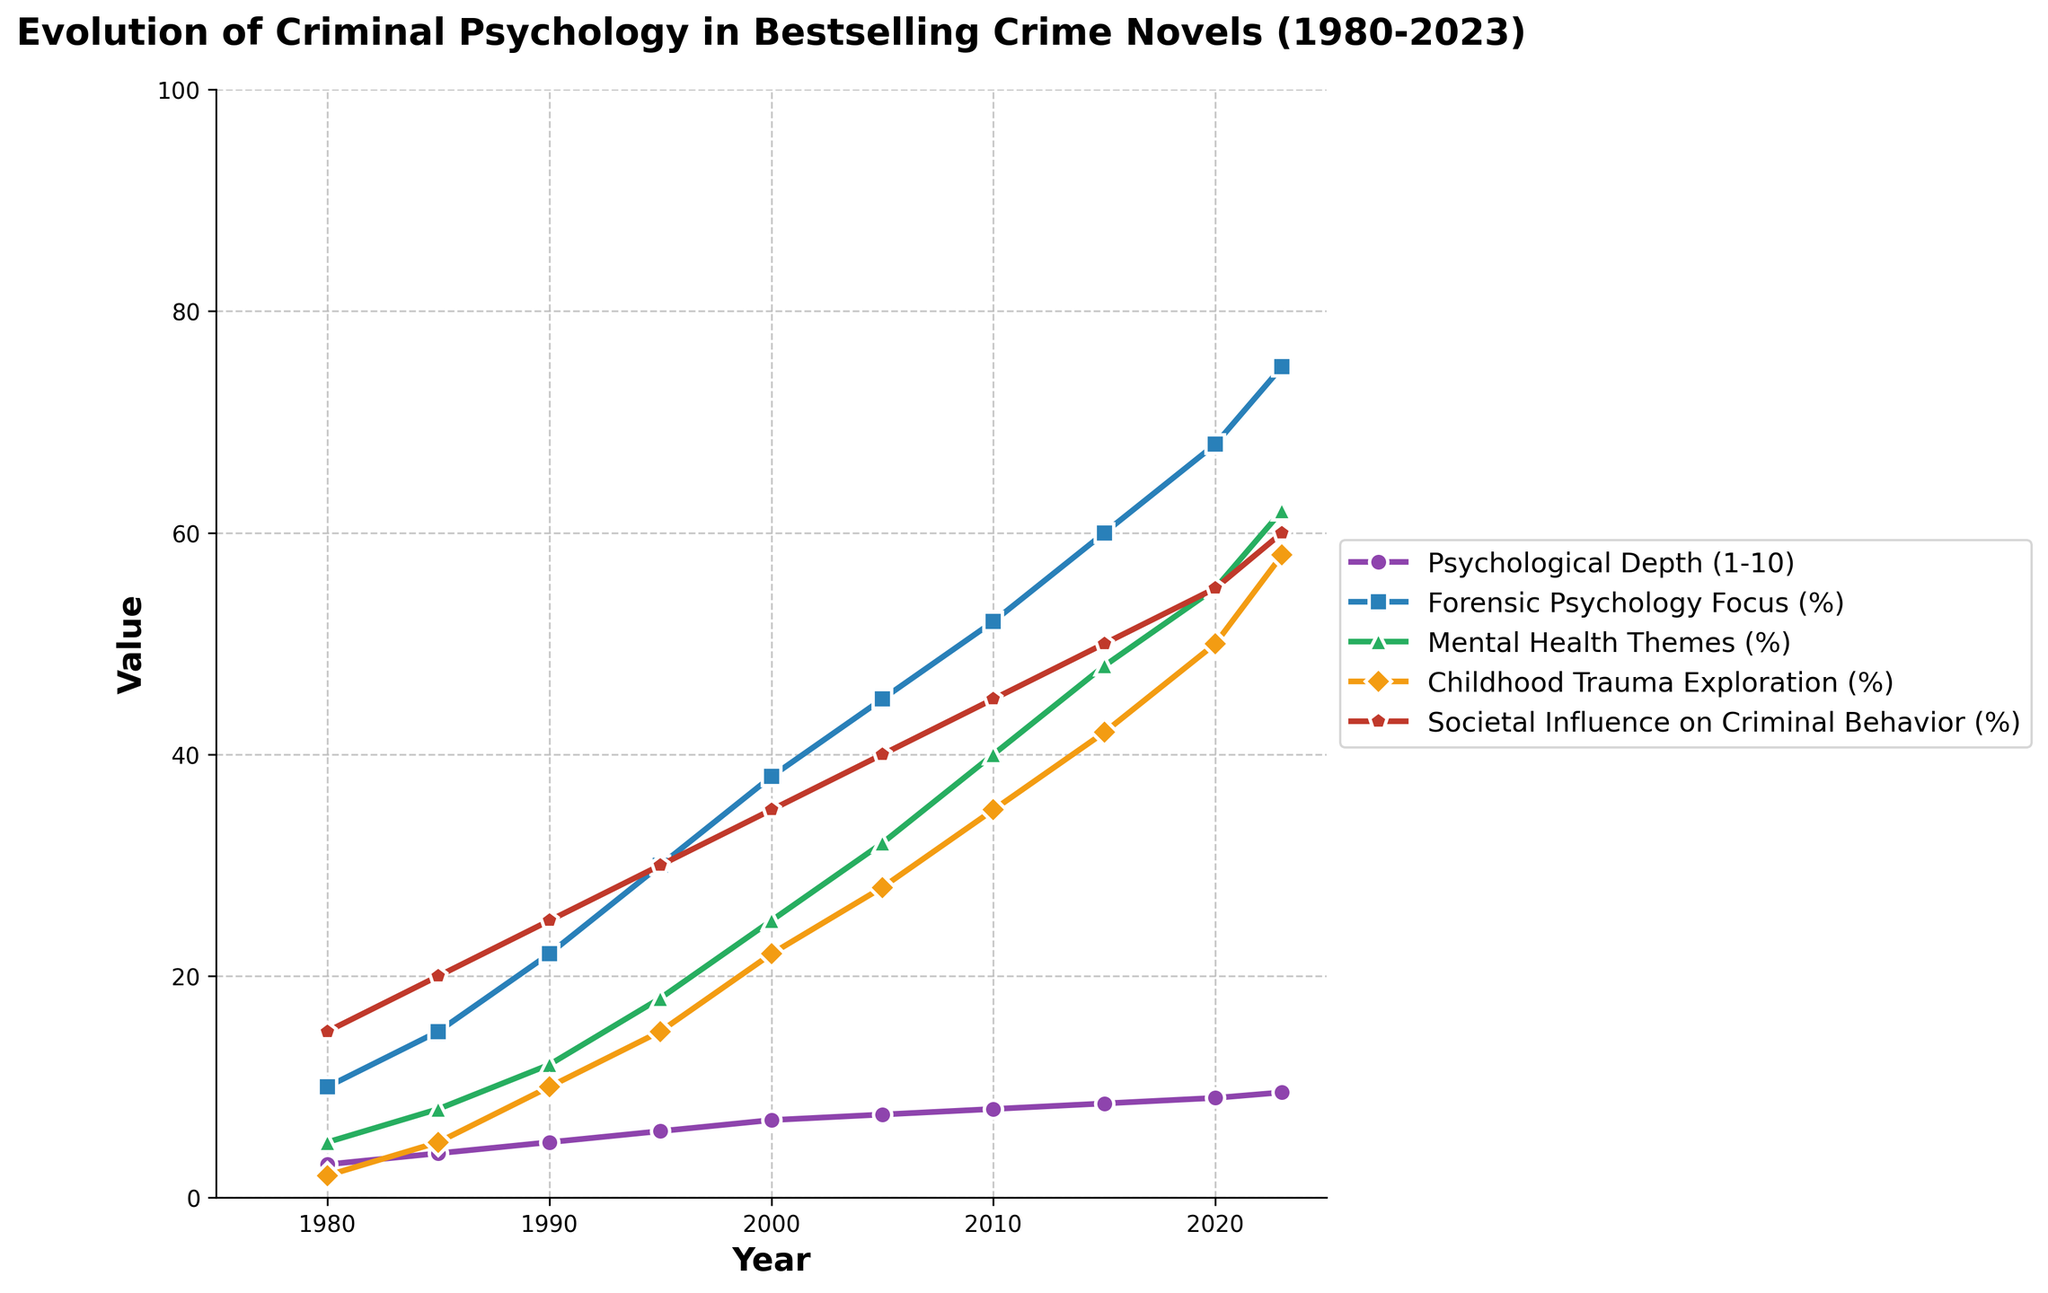What is the overall trend in the Psychological Depth metric from 1980 to 2023? The Psychological Depth metric shows a general increasing trend from 1980, starting at a value of 3, to 2023, reaching a value of 9.5.
Answer: Increasing How much did the Forensic Psychology Focus percentage increase from 1980 to 2023? In 1980, the Forensic Psychology Focus was 10%, and by 2023, it had increased to 75%. The increase is calculated as 75% - 10% = 65%.
Answer: 65% Which year saw the highest percentage increase in Childhood Trauma Exploration compared to the previous year? The year 2020 saw an increase from 50% in 2015 to 58%, which is the highest percentage increase of 8%.
Answer: 2020 Compare the Mental Health Themes (%) in 1990 and 2010. Which year had a higher percentage, and by how much? In 1990, the Mental Health Themes percentage was 12%. In 2010, it was 40%. The difference is 40% - 12% = 28%.
Answer: 2010 by 28% What is the average percentage of Societal Influence on Criminal Behavior over the given period (1980 to 2023)? Sum the percentage values: 15 + 20 + 25 + 30 + 35 + 40 + 45 + 50 + 55 + 60 = 375. The average is 375/10 = 37.5%.
Answer: 37.5% By how many units did the Psychological Depth metric change from 1985 to 1995? The Psychological Depth metric was 4 in 1985 and 6 in 1995. The change is 6 - 4 = 2 units.
Answer: 2 units During which period (5-year intervals) did the Forensic Psychology Focus percentage see the smallest increase? The smallest increase occurs between 2020 (68%) and 2023 (75%), which is an increase of 7%.
Answer: 2020-2023 Which metric had the highest value in 2023, and what was the value? In 2023, the metric with the highest value was Forensic Psychology Focus at 75%.
Answer: Forensic Psychology Focus, 75% How did the Mental Health Themes percentage change from 2000 to 2020? The Mental Health Themes percentage increased from 25% in 2000 to 55% in 2020, which is an increase of 30%.
Answer: Increased by 30% In which year did the Societal Influence on Criminal Behavior percentage reach 40%? The Societal Influence on Criminal Behavior percentage reached 40% in 2005.
Answer: 2005 